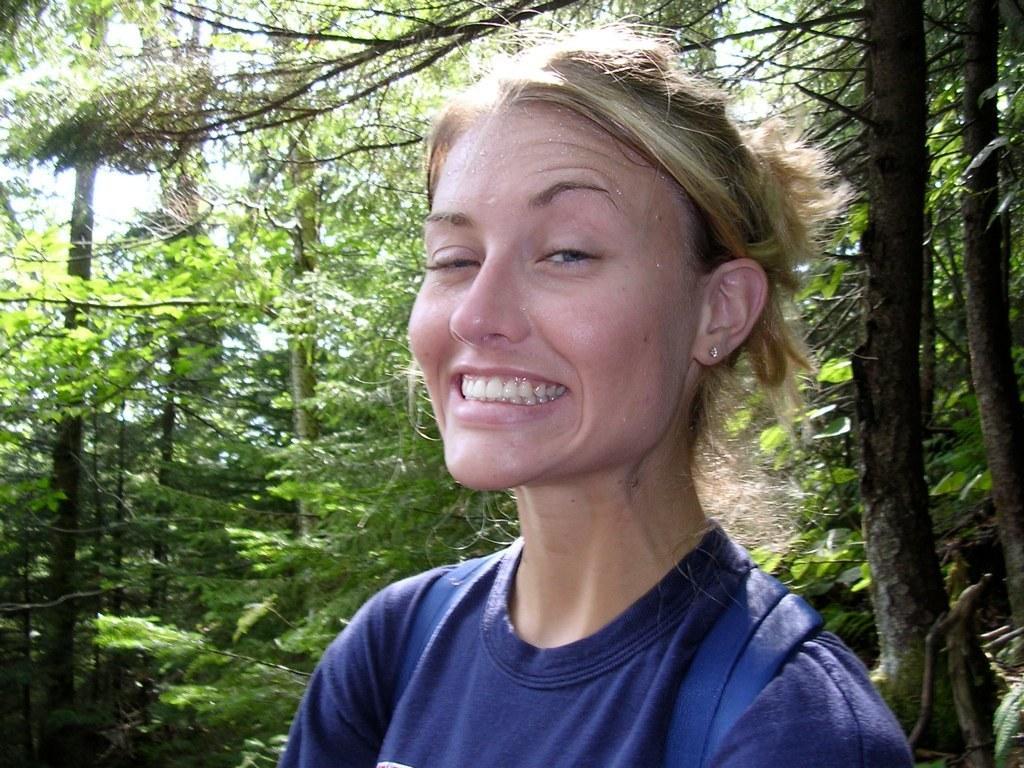Describe this image in one or two sentences. In the picture I can see a woman and there is a smile on her face. She is wearing a T-shirt and looks like she is carrying a bag on her back. In the background, I can see the trees. I can see the trunk of trees on the right side. 